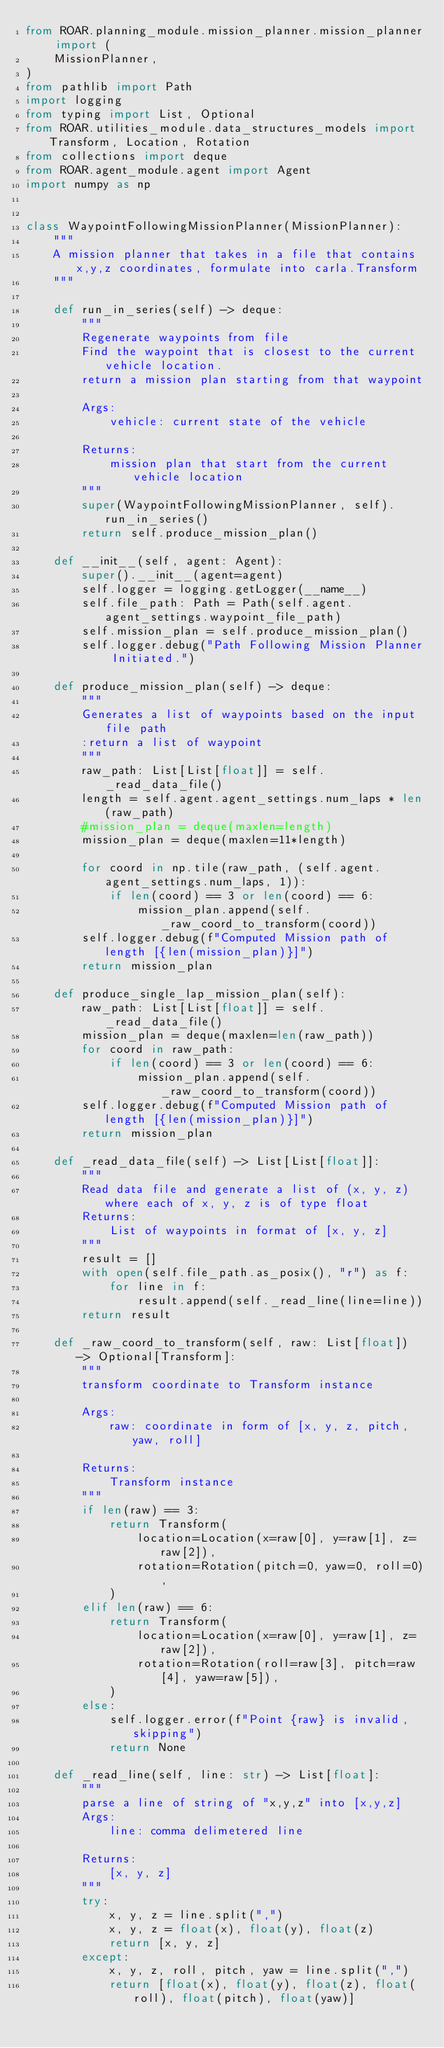Convert code to text. <code><loc_0><loc_0><loc_500><loc_500><_Python_>from ROAR.planning_module.mission_planner.mission_planner import (
    MissionPlanner,
)
from pathlib import Path
import logging
from typing import List, Optional
from ROAR.utilities_module.data_structures_models import Transform, Location, Rotation
from collections import deque
from ROAR.agent_module.agent import Agent
import numpy as np


class WaypointFollowingMissionPlanner(MissionPlanner):
    """
    A mission planner that takes in a file that contains x,y,z coordinates, formulate into carla.Transform
    """

    def run_in_series(self) -> deque:
        """
        Regenerate waypoints from file
        Find the waypoint that is closest to the current vehicle location.
        return a mission plan starting from that waypoint

        Args:
            vehicle: current state of the vehicle

        Returns:
            mission plan that start from the current vehicle location
        """
        super(WaypointFollowingMissionPlanner, self).run_in_series()
        return self.produce_mission_plan()

    def __init__(self, agent: Agent):
        super().__init__(agent=agent)
        self.logger = logging.getLogger(__name__)
        self.file_path: Path = Path(self.agent.agent_settings.waypoint_file_path)
        self.mission_plan = self.produce_mission_plan()
        self.logger.debug("Path Following Mission Planner Initiated.")

    def produce_mission_plan(self) -> deque:
        """
        Generates a list of waypoints based on the input file path
        :return a list of waypoint
        """
        raw_path: List[List[float]] = self._read_data_file()
        length = self.agent.agent_settings.num_laps * len(raw_path)
        #mission_plan = deque(maxlen=length)
        mission_plan = deque(maxlen=11*length)

        for coord in np.tile(raw_path, (self.agent.agent_settings.num_laps, 1)):
            if len(coord) == 3 or len(coord) == 6:
                mission_plan.append(self._raw_coord_to_transform(coord))
        self.logger.debug(f"Computed Mission path of length [{len(mission_plan)}]")
        return mission_plan

    def produce_single_lap_mission_plan(self):
        raw_path: List[List[float]] = self._read_data_file()
        mission_plan = deque(maxlen=len(raw_path))
        for coord in raw_path:
            if len(coord) == 3 or len(coord) == 6:
                mission_plan.append(self._raw_coord_to_transform(coord))
        self.logger.debug(f"Computed Mission path of length [{len(mission_plan)}]")
        return mission_plan

    def _read_data_file(self) -> List[List[float]]:
        """
        Read data file and generate a list of (x, y, z) where each of x, y, z is of type float
        Returns:
            List of waypoints in format of [x, y, z]
        """
        result = []
        with open(self.file_path.as_posix(), "r") as f:
            for line in f:
                result.append(self._read_line(line=line))
        return result

    def _raw_coord_to_transform(self, raw: List[float]) -> Optional[Transform]:
        """
        transform coordinate to Transform instance

        Args:
            raw: coordinate in form of [x, y, z, pitch, yaw, roll]

        Returns:
            Transform instance
        """
        if len(raw) == 3:
            return Transform(
                location=Location(x=raw[0], y=raw[1], z=raw[2]),
                rotation=Rotation(pitch=0, yaw=0, roll=0),
            )
        elif len(raw) == 6:
            return Transform(
                location=Location(x=raw[0], y=raw[1], z=raw[2]),
                rotation=Rotation(roll=raw[3], pitch=raw[4], yaw=raw[5]),
            )
        else:
            self.logger.error(f"Point {raw} is invalid, skipping")
            return None

    def _read_line(self, line: str) -> List[float]:
        """
        parse a line of string of "x,y,z" into [x,y,z]
        Args:
            line: comma delimetered line

        Returns:
            [x, y, z]
        """
        try:
            x, y, z = line.split(",")
            x, y, z = float(x), float(y), float(z)
            return [x, y, z]
        except:
            x, y, z, roll, pitch, yaw = line.split(",")
            return [float(x), float(y), float(z), float(roll), float(pitch), float(yaw)]
</code> 